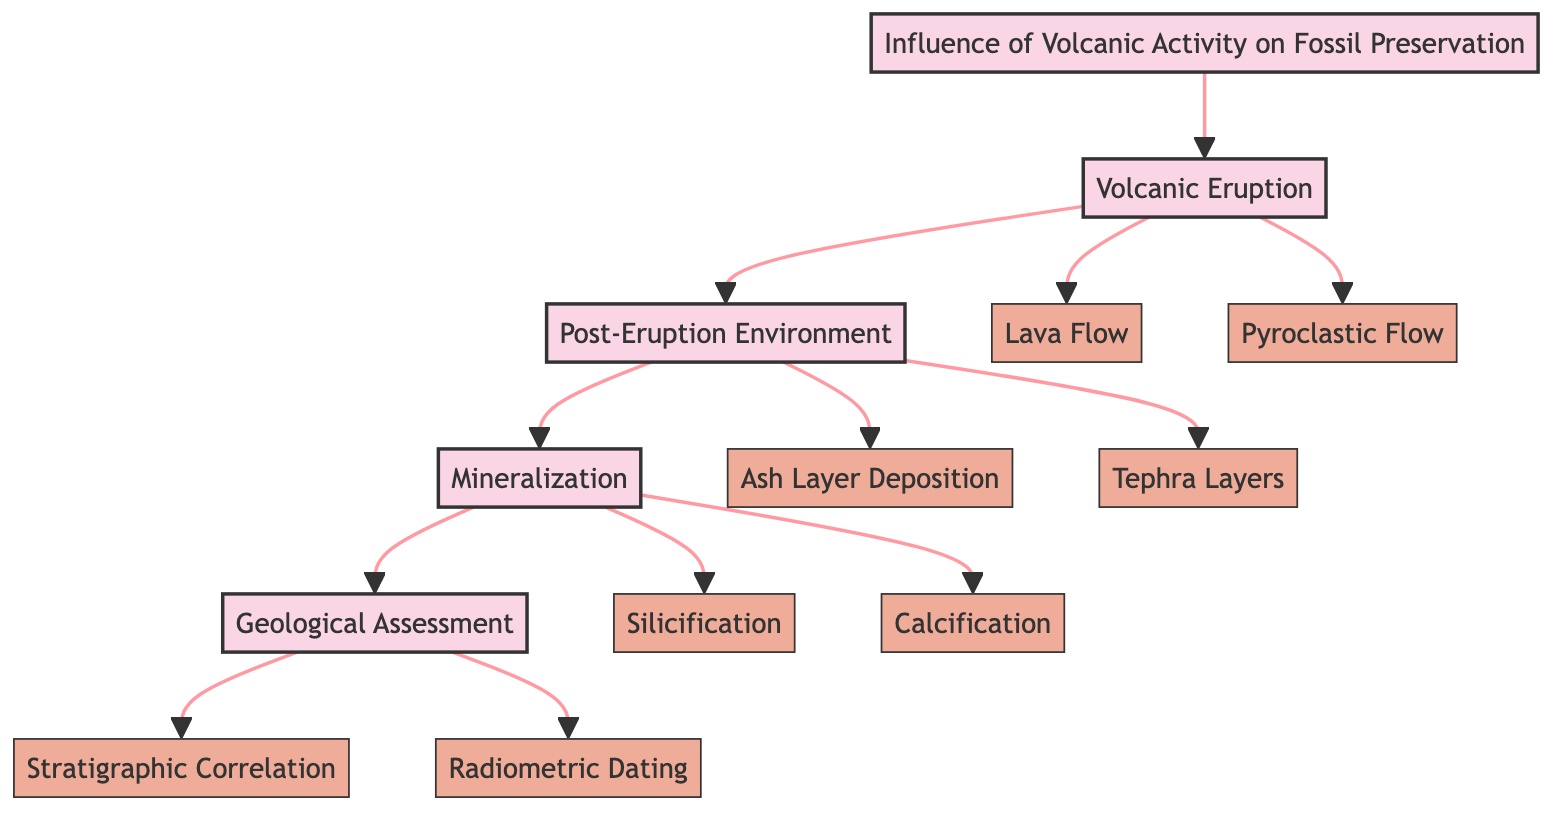What is the title of the clinical pathway? The title is stated at the top of the diagram, directly identifying the overall focus of the pathway.
Answer: Influence of Volcanic Activity on Fossil Preservation How many stages are in the clinical pathway? By counting the number of distinct stages represented in the diagram, we can see that there are four identified stages.
Answer: 4 What element comes after "Volcanic Eruption"? The diagram shows a clear directional flow, indicating that "Post-Eruption Environment" follows "Volcanic Eruption" in the pathway.
Answer: Post-Eruption Environment Which preservation method involves the replacement of organic material with silica? Among the elements listed under "Mineralization," "Silicification" is specifically described as the process involving silica replacing organic material in fossils.
Answer: Silicification What is a key benefit of "Ash Layer Deposition"? The description associated with "Ash Layer Deposition" indicates that it creates an anoxic environment, which aids in the preservation of fossils.
Answer: Anoxic environment What does "Radiometric Dating" help to achieve? The description of "Radiometric Dating" specifies that it uses isotopes within volcanic layers to accurately date fossils, establishing its purpose within the pathway.
Answer: Accurately date fossils What connects "Stratigraphic Correlation" to the preservation timeline? The function of "Stratigraphic Correlation" involves matching volcanic ash layers with fossil records, which is essential for understanding the timeline of preservation.
Answer: Timeline of preservation Which element represents a type of volcanic matter that can instantly fossilize organisms? The element "Pyroclastic Flow" is specifically described as hot gas and volcanic matter capable of causing rapid burial, leading to instant fossilization.
Answer: Pyroclastic Flow 